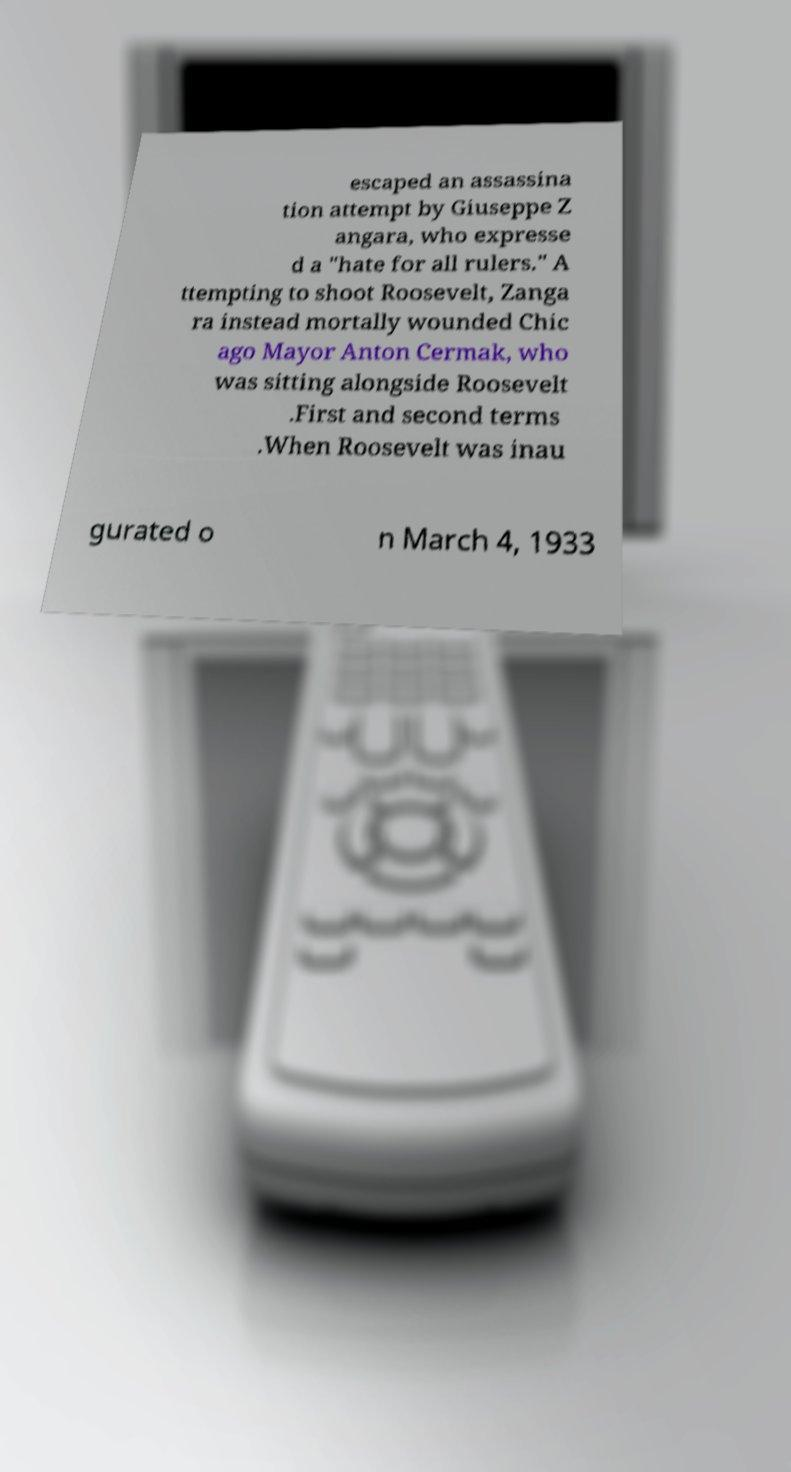Please read and relay the text visible in this image. What does it say? escaped an assassina tion attempt by Giuseppe Z angara, who expresse d a "hate for all rulers." A ttempting to shoot Roosevelt, Zanga ra instead mortally wounded Chic ago Mayor Anton Cermak, who was sitting alongside Roosevelt .First and second terms .When Roosevelt was inau gurated o n March 4, 1933 